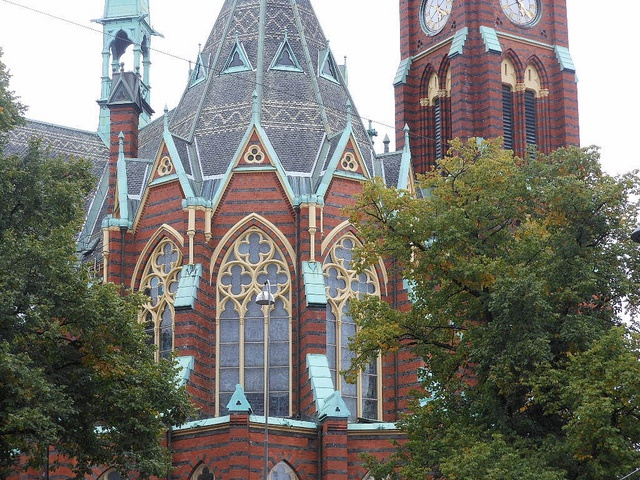Describe the objects in this image and their specific colors. I can see clock in white, lightgray, darkgray, and gray tones and clock in white, lightgray, darkgray, and gray tones in this image. 